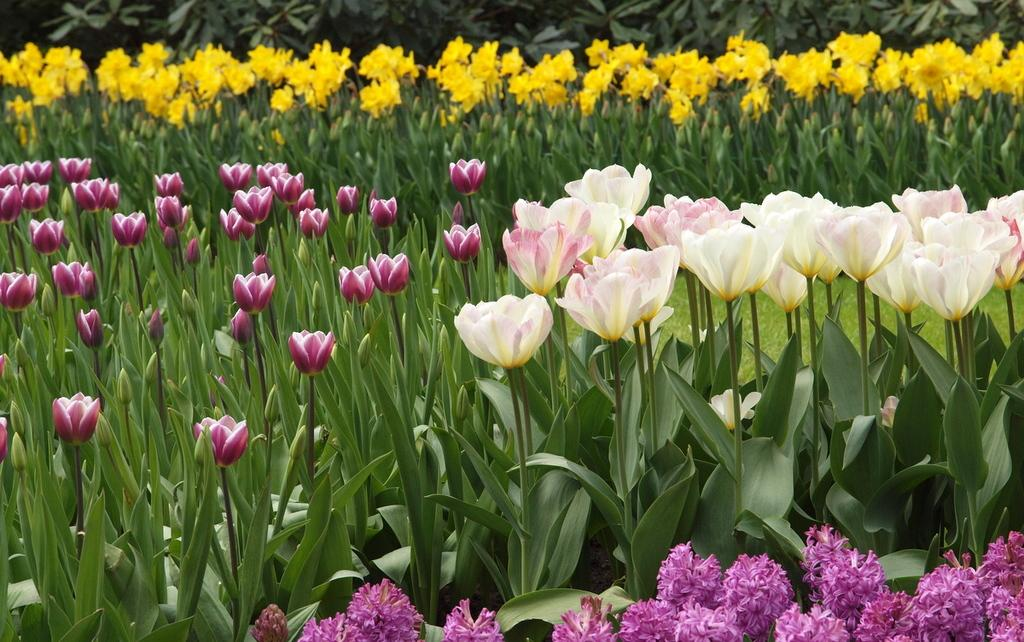What type of living organisms can be seen in the image? Plants and flowers are visible in the image. Can you describe the flowers in the image? The flowers in the image are part of the plants. What type of secretary can be seen working in the image? There is no secretary present in the image; it features plants and flowers. What type of care is being provided to the spot in the image? There is no spot present in the image, and therefore no care is being provided. 